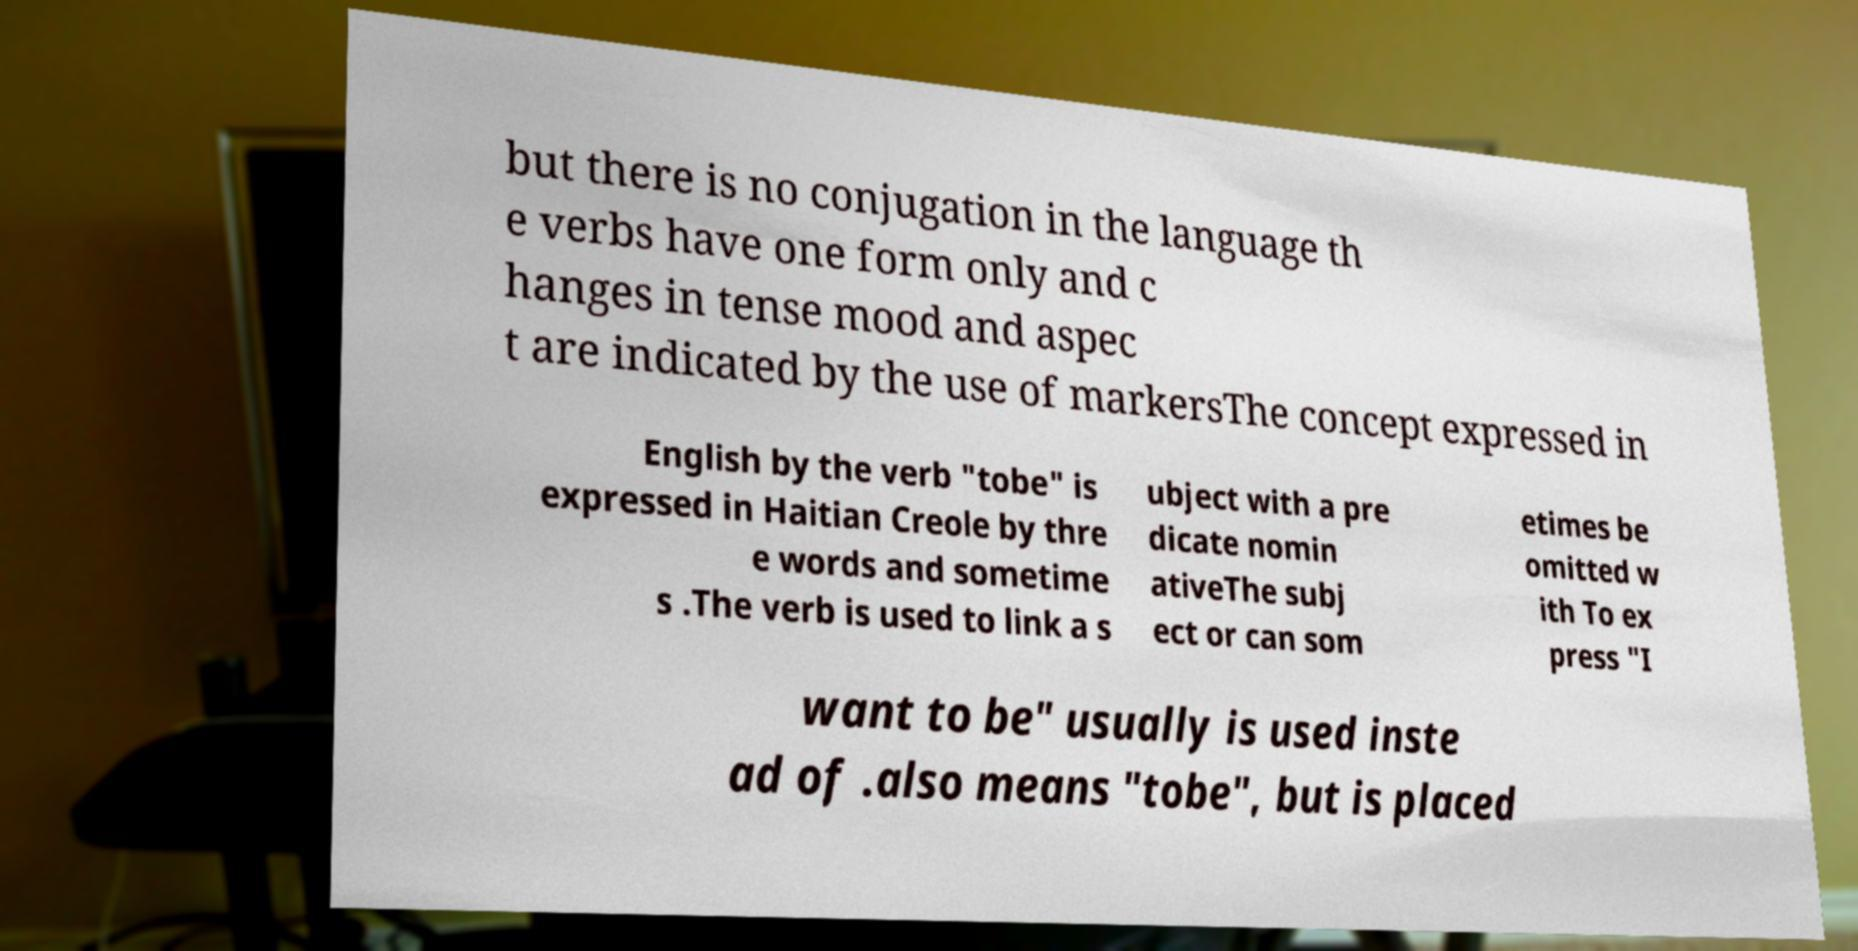Could you assist in decoding the text presented in this image and type it out clearly? but there is no conjugation in the language th e verbs have one form only and c hanges in tense mood and aspec t are indicated by the use of markersThe concept expressed in English by the verb "tobe" is expressed in Haitian Creole by thre e words and sometime s .The verb is used to link a s ubject with a pre dicate nomin ativeThe subj ect or can som etimes be omitted w ith To ex press "I want to be" usually is used inste ad of .also means "tobe", but is placed 